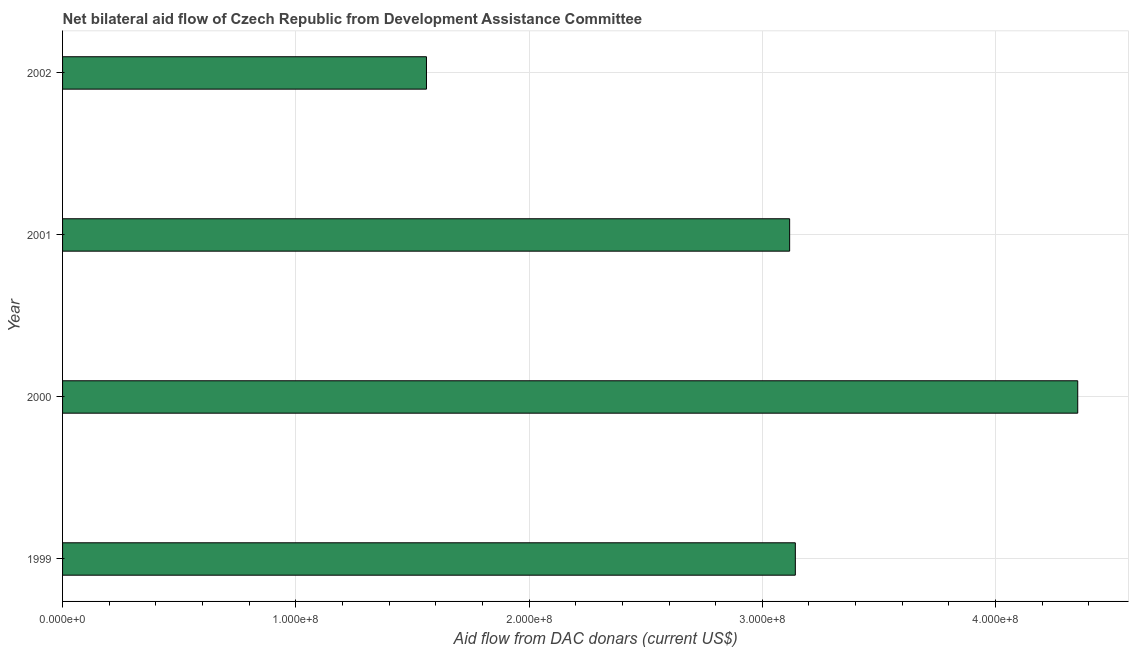Does the graph contain grids?
Ensure brevity in your answer.  Yes. What is the title of the graph?
Your answer should be compact. Net bilateral aid flow of Czech Republic from Development Assistance Committee. What is the label or title of the X-axis?
Give a very brief answer. Aid flow from DAC donars (current US$). What is the label or title of the Y-axis?
Keep it short and to the point. Year. What is the net bilateral aid flows from dac donors in 2000?
Your answer should be very brief. 4.35e+08. Across all years, what is the maximum net bilateral aid flows from dac donors?
Your answer should be compact. 4.35e+08. Across all years, what is the minimum net bilateral aid flows from dac donors?
Give a very brief answer. 1.56e+08. What is the sum of the net bilateral aid flows from dac donors?
Your answer should be very brief. 1.22e+09. What is the difference between the net bilateral aid flows from dac donors in 1999 and 2002?
Give a very brief answer. 1.58e+08. What is the average net bilateral aid flows from dac donors per year?
Offer a very short reply. 3.04e+08. What is the median net bilateral aid flows from dac donors?
Make the answer very short. 3.13e+08. In how many years, is the net bilateral aid flows from dac donors greater than 280000000 US$?
Your answer should be very brief. 3. Do a majority of the years between 2002 and 1999 (inclusive) have net bilateral aid flows from dac donors greater than 80000000 US$?
Your response must be concise. Yes. What is the ratio of the net bilateral aid flows from dac donors in 2001 to that in 2002?
Provide a succinct answer. 2. Is the net bilateral aid flows from dac donors in 1999 less than that in 2001?
Offer a very short reply. No. What is the difference between the highest and the second highest net bilateral aid flows from dac donors?
Offer a terse response. 1.21e+08. Is the sum of the net bilateral aid flows from dac donors in 1999 and 2002 greater than the maximum net bilateral aid flows from dac donors across all years?
Keep it short and to the point. Yes. What is the difference between the highest and the lowest net bilateral aid flows from dac donors?
Provide a short and direct response. 2.79e+08. Are all the bars in the graph horizontal?
Your answer should be very brief. Yes. How many years are there in the graph?
Provide a short and direct response. 4. What is the difference between two consecutive major ticks on the X-axis?
Your answer should be compact. 1.00e+08. Are the values on the major ticks of X-axis written in scientific E-notation?
Your answer should be very brief. Yes. What is the Aid flow from DAC donars (current US$) in 1999?
Your answer should be very brief. 3.14e+08. What is the Aid flow from DAC donars (current US$) of 2000?
Your response must be concise. 4.35e+08. What is the Aid flow from DAC donars (current US$) of 2001?
Give a very brief answer. 3.12e+08. What is the Aid flow from DAC donars (current US$) in 2002?
Offer a very short reply. 1.56e+08. What is the difference between the Aid flow from DAC donars (current US$) in 1999 and 2000?
Keep it short and to the point. -1.21e+08. What is the difference between the Aid flow from DAC donars (current US$) in 1999 and 2001?
Your answer should be compact. 2.44e+06. What is the difference between the Aid flow from DAC donars (current US$) in 1999 and 2002?
Your answer should be compact. 1.58e+08. What is the difference between the Aid flow from DAC donars (current US$) in 2000 and 2001?
Ensure brevity in your answer.  1.24e+08. What is the difference between the Aid flow from DAC donars (current US$) in 2000 and 2002?
Give a very brief answer. 2.79e+08. What is the difference between the Aid flow from DAC donars (current US$) in 2001 and 2002?
Ensure brevity in your answer.  1.56e+08. What is the ratio of the Aid flow from DAC donars (current US$) in 1999 to that in 2000?
Keep it short and to the point. 0.72. What is the ratio of the Aid flow from DAC donars (current US$) in 1999 to that in 2001?
Provide a short and direct response. 1.01. What is the ratio of the Aid flow from DAC donars (current US$) in 1999 to that in 2002?
Keep it short and to the point. 2.01. What is the ratio of the Aid flow from DAC donars (current US$) in 2000 to that in 2001?
Your answer should be very brief. 1.4. What is the ratio of the Aid flow from DAC donars (current US$) in 2000 to that in 2002?
Keep it short and to the point. 2.79. What is the ratio of the Aid flow from DAC donars (current US$) in 2001 to that in 2002?
Provide a short and direct response. 2. 